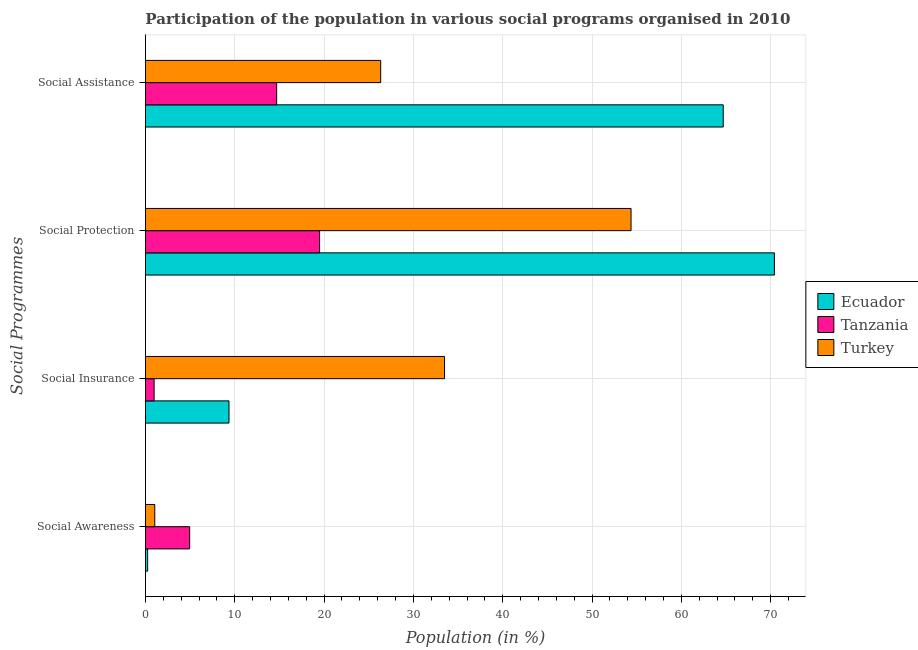How many groups of bars are there?
Your answer should be compact. 4. How many bars are there on the 3rd tick from the top?
Your answer should be compact. 3. What is the label of the 4th group of bars from the top?
Your answer should be very brief. Social Awareness. What is the participation of population in social awareness programs in Ecuador?
Your answer should be very brief. 0.25. Across all countries, what is the maximum participation of population in social protection programs?
Give a very brief answer. 70.42. Across all countries, what is the minimum participation of population in social insurance programs?
Provide a succinct answer. 0.97. In which country was the participation of population in social awareness programs maximum?
Offer a very short reply. Tanzania. In which country was the participation of population in social protection programs minimum?
Provide a succinct answer. Tanzania. What is the total participation of population in social awareness programs in the graph?
Offer a terse response. 6.24. What is the difference between the participation of population in social insurance programs in Ecuador and that in Turkey?
Make the answer very short. -24.13. What is the difference between the participation of population in social awareness programs in Turkey and the participation of population in social insurance programs in Tanzania?
Keep it short and to the point. 0.08. What is the average participation of population in social awareness programs per country?
Your answer should be compact. 2.08. What is the difference between the participation of population in social assistance programs and participation of population in social insurance programs in Ecuador?
Keep it short and to the point. 55.33. What is the ratio of the participation of population in social insurance programs in Ecuador to that in Turkey?
Your answer should be compact. 0.28. Is the participation of population in social awareness programs in Tanzania less than that in Turkey?
Offer a terse response. No. Is the difference between the participation of population in social assistance programs in Ecuador and Tanzania greater than the difference between the participation of population in social insurance programs in Ecuador and Tanzania?
Offer a terse response. Yes. What is the difference between the highest and the second highest participation of population in social awareness programs?
Offer a very short reply. 3.91. What is the difference between the highest and the lowest participation of population in social protection programs?
Your answer should be very brief. 50.92. In how many countries, is the participation of population in social insurance programs greater than the average participation of population in social insurance programs taken over all countries?
Make the answer very short. 1. What does the 3rd bar from the top in Social Assistance represents?
Keep it short and to the point. Ecuador. What does the 1st bar from the bottom in Social Protection represents?
Your answer should be compact. Ecuador. Is it the case that in every country, the sum of the participation of population in social awareness programs and participation of population in social insurance programs is greater than the participation of population in social protection programs?
Provide a succinct answer. No. How many bars are there?
Make the answer very short. 12. Are all the bars in the graph horizontal?
Provide a short and direct response. Yes. What is the difference between two consecutive major ticks on the X-axis?
Your answer should be very brief. 10. Does the graph contain grids?
Make the answer very short. Yes. Where does the legend appear in the graph?
Offer a terse response. Center right. How many legend labels are there?
Your answer should be very brief. 3. What is the title of the graph?
Keep it short and to the point. Participation of the population in various social programs organised in 2010. What is the label or title of the X-axis?
Provide a short and direct response. Population (in %). What is the label or title of the Y-axis?
Your answer should be very brief. Social Programmes. What is the Population (in %) in Ecuador in Social Awareness?
Your answer should be compact. 0.25. What is the Population (in %) in Tanzania in Social Awareness?
Make the answer very short. 4.95. What is the Population (in %) of Turkey in Social Awareness?
Make the answer very short. 1.04. What is the Population (in %) of Ecuador in Social Insurance?
Ensure brevity in your answer.  9.35. What is the Population (in %) of Tanzania in Social Insurance?
Ensure brevity in your answer.  0.97. What is the Population (in %) in Turkey in Social Insurance?
Provide a succinct answer. 33.49. What is the Population (in %) of Ecuador in Social Protection?
Your answer should be very brief. 70.42. What is the Population (in %) in Tanzania in Social Protection?
Offer a very short reply. 19.5. What is the Population (in %) in Turkey in Social Protection?
Give a very brief answer. 54.37. What is the Population (in %) of Ecuador in Social Assistance?
Provide a succinct answer. 64.69. What is the Population (in %) in Tanzania in Social Assistance?
Offer a terse response. 14.69. What is the Population (in %) of Turkey in Social Assistance?
Keep it short and to the point. 26.34. Across all Social Programmes, what is the maximum Population (in %) of Ecuador?
Provide a short and direct response. 70.42. Across all Social Programmes, what is the maximum Population (in %) in Tanzania?
Make the answer very short. 19.5. Across all Social Programmes, what is the maximum Population (in %) in Turkey?
Your answer should be compact. 54.37. Across all Social Programmes, what is the minimum Population (in %) of Ecuador?
Ensure brevity in your answer.  0.25. Across all Social Programmes, what is the minimum Population (in %) in Tanzania?
Provide a short and direct response. 0.97. Across all Social Programmes, what is the minimum Population (in %) in Turkey?
Ensure brevity in your answer.  1.04. What is the total Population (in %) in Ecuador in the graph?
Provide a short and direct response. 144.71. What is the total Population (in %) in Tanzania in the graph?
Provide a short and direct response. 40.11. What is the total Population (in %) in Turkey in the graph?
Offer a terse response. 115.24. What is the difference between the Population (in %) of Ecuador in Social Awareness and that in Social Insurance?
Give a very brief answer. -9.11. What is the difference between the Population (in %) in Tanzania in Social Awareness and that in Social Insurance?
Your answer should be compact. 3.98. What is the difference between the Population (in %) in Turkey in Social Awareness and that in Social Insurance?
Provide a succinct answer. -32.44. What is the difference between the Population (in %) in Ecuador in Social Awareness and that in Social Protection?
Make the answer very short. -70.17. What is the difference between the Population (in %) in Tanzania in Social Awareness and that in Social Protection?
Your answer should be very brief. -14.54. What is the difference between the Population (in %) in Turkey in Social Awareness and that in Social Protection?
Provide a succinct answer. -53.32. What is the difference between the Population (in %) in Ecuador in Social Awareness and that in Social Assistance?
Give a very brief answer. -64.44. What is the difference between the Population (in %) in Tanzania in Social Awareness and that in Social Assistance?
Your answer should be very brief. -9.74. What is the difference between the Population (in %) of Turkey in Social Awareness and that in Social Assistance?
Ensure brevity in your answer.  -25.29. What is the difference between the Population (in %) in Ecuador in Social Insurance and that in Social Protection?
Provide a succinct answer. -61.06. What is the difference between the Population (in %) of Tanzania in Social Insurance and that in Social Protection?
Provide a succinct answer. -18.53. What is the difference between the Population (in %) in Turkey in Social Insurance and that in Social Protection?
Offer a very short reply. -20.88. What is the difference between the Population (in %) of Ecuador in Social Insurance and that in Social Assistance?
Offer a very short reply. -55.33. What is the difference between the Population (in %) of Tanzania in Social Insurance and that in Social Assistance?
Keep it short and to the point. -13.72. What is the difference between the Population (in %) of Turkey in Social Insurance and that in Social Assistance?
Your answer should be compact. 7.15. What is the difference between the Population (in %) in Ecuador in Social Protection and that in Social Assistance?
Provide a succinct answer. 5.73. What is the difference between the Population (in %) in Tanzania in Social Protection and that in Social Assistance?
Keep it short and to the point. 4.81. What is the difference between the Population (in %) in Turkey in Social Protection and that in Social Assistance?
Provide a short and direct response. 28.03. What is the difference between the Population (in %) of Ecuador in Social Awareness and the Population (in %) of Tanzania in Social Insurance?
Ensure brevity in your answer.  -0.72. What is the difference between the Population (in %) in Ecuador in Social Awareness and the Population (in %) in Turkey in Social Insurance?
Offer a terse response. -33.24. What is the difference between the Population (in %) in Tanzania in Social Awareness and the Population (in %) in Turkey in Social Insurance?
Provide a succinct answer. -28.54. What is the difference between the Population (in %) of Ecuador in Social Awareness and the Population (in %) of Tanzania in Social Protection?
Provide a short and direct response. -19.25. What is the difference between the Population (in %) in Ecuador in Social Awareness and the Population (in %) in Turkey in Social Protection?
Your answer should be compact. -54.12. What is the difference between the Population (in %) of Tanzania in Social Awareness and the Population (in %) of Turkey in Social Protection?
Your answer should be very brief. -49.42. What is the difference between the Population (in %) in Ecuador in Social Awareness and the Population (in %) in Tanzania in Social Assistance?
Ensure brevity in your answer.  -14.44. What is the difference between the Population (in %) in Ecuador in Social Awareness and the Population (in %) in Turkey in Social Assistance?
Your answer should be very brief. -26.09. What is the difference between the Population (in %) in Tanzania in Social Awareness and the Population (in %) in Turkey in Social Assistance?
Your answer should be compact. -21.39. What is the difference between the Population (in %) of Ecuador in Social Insurance and the Population (in %) of Tanzania in Social Protection?
Ensure brevity in your answer.  -10.14. What is the difference between the Population (in %) in Ecuador in Social Insurance and the Population (in %) in Turkey in Social Protection?
Your response must be concise. -45.01. What is the difference between the Population (in %) in Tanzania in Social Insurance and the Population (in %) in Turkey in Social Protection?
Your answer should be compact. -53.4. What is the difference between the Population (in %) in Ecuador in Social Insurance and the Population (in %) in Tanzania in Social Assistance?
Your answer should be compact. -5.34. What is the difference between the Population (in %) in Ecuador in Social Insurance and the Population (in %) in Turkey in Social Assistance?
Give a very brief answer. -16.98. What is the difference between the Population (in %) of Tanzania in Social Insurance and the Population (in %) of Turkey in Social Assistance?
Your answer should be compact. -25.37. What is the difference between the Population (in %) in Ecuador in Social Protection and the Population (in %) in Tanzania in Social Assistance?
Your response must be concise. 55.73. What is the difference between the Population (in %) of Ecuador in Social Protection and the Population (in %) of Turkey in Social Assistance?
Offer a terse response. 44.08. What is the difference between the Population (in %) in Tanzania in Social Protection and the Population (in %) in Turkey in Social Assistance?
Provide a short and direct response. -6.84. What is the average Population (in %) of Ecuador per Social Programmes?
Your answer should be compact. 36.18. What is the average Population (in %) of Tanzania per Social Programmes?
Your answer should be very brief. 10.03. What is the average Population (in %) in Turkey per Social Programmes?
Offer a very short reply. 28.81. What is the difference between the Population (in %) of Ecuador and Population (in %) of Tanzania in Social Awareness?
Ensure brevity in your answer.  -4.71. What is the difference between the Population (in %) of Ecuador and Population (in %) of Turkey in Social Awareness?
Keep it short and to the point. -0.8. What is the difference between the Population (in %) of Tanzania and Population (in %) of Turkey in Social Awareness?
Your response must be concise. 3.91. What is the difference between the Population (in %) of Ecuador and Population (in %) of Tanzania in Social Insurance?
Provide a short and direct response. 8.39. What is the difference between the Population (in %) of Ecuador and Population (in %) of Turkey in Social Insurance?
Make the answer very short. -24.13. What is the difference between the Population (in %) in Tanzania and Population (in %) in Turkey in Social Insurance?
Your answer should be compact. -32.52. What is the difference between the Population (in %) in Ecuador and Population (in %) in Tanzania in Social Protection?
Offer a terse response. 50.92. What is the difference between the Population (in %) in Ecuador and Population (in %) in Turkey in Social Protection?
Keep it short and to the point. 16.05. What is the difference between the Population (in %) of Tanzania and Population (in %) of Turkey in Social Protection?
Provide a short and direct response. -34.87. What is the difference between the Population (in %) in Ecuador and Population (in %) in Tanzania in Social Assistance?
Provide a short and direct response. 50. What is the difference between the Population (in %) of Ecuador and Population (in %) of Turkey in Social Assistance?
Your response must be concise. 38.35. What is the difference between the Population (in %) of Tanzania and Population (in %) of Turkey in Social Assistance?
Your answer should be compact. -11.65. What is the ratio of the Population (in %) in Ecuador in Social Awareness to that in Social Insurance?
Give a very brief answer. 0.03. What is the ratio of the Population (in %) of Tanzania in Social Awareness to that in Social Insurance?
Give a very brief answer. 5.11. What is the ratio of the Population (in %) of Turkey in Social Awareness to that in Social Insurance?
Ensure brevity in your answer.  0.03. What is the ratio of the Population (in %) in Ecuador in Social Awareness to that in Social Protection?
Make the answer very short. 0. What is the ratio of the Population (in %) of Tanzania in Social Awareness to that in Social Protection?
Your response must be concise. 0.25. What is the ratio of the Population (in %) in Turkey in Social Awareness to that in Social Protection?
Ensure brevity in your answer.  0.02. What is the ratio of the Population (in %) in Ecuador in Social Awareness to that in Social Assistance?
Your answer should be compact. 0. What is the ratio of the Population (in %) of Tanzania in Social Awareness to that in Social Assistance?
Ensure brevity in your answer.  0.34. What is the ratio of the Population (in %) of Turkey in Social Awareness to that in Social Assistance?
Provide a short and direct response. 0.04. What is the ratio of the Population (in %) in Ecuador in Social Insurance to that in Social Protection?
Your response must be concise. 0.13. What is the ratio of the Population (in %) of Tanzania in Social Insurance to that in Social Protection?
Your response must be concise. 0.05. What is the ratio of the Population (in %) in Turkey in Social Insurance to that in Social Protection?
Offer a very short reply. 0.62. What is the ratio of the Population (in %) in Ecuador in Social Insurance to that in Social Assistance?
Your response must be concise. 0.14. What is the ratio of the Population (in %) in Tanzania in Social Insurance to that in Social Assistance?
Your answer should be very brief. 0.07. What is the ratio of the Population (in %) in Turkey in Social Insurance to that in Social Assistance?
Provide a short and direct response. 1.27. What is the ratio of the Population (in %) of Ecuador in Social Protection to that in Social Assistance?
Give a very brief answer. 1.09. What is the ratio of the Population (in %) of Tanzania in Social Protection to that in Social Assistance?
Ensure brevity in your answer.  1.33. What is the ratio of the Population (in %) in Turkey in Social Protection to that in Social Assistance?
Keep it short and to the point. 2.06. What is the difference between the highest and the second highest Population (in %) in Ecuador?
Keep it short and to the point. 5.73. What is the difference between the highest and the second highest Population (in %) of Tanzania?
Your answer should be very brief. 4.81. What is the difference between the highest and the second highest Population (in %) of Turkey?
Offer a terse response. 20.88. What is the difference between the highest and the lowest Population (in %) of Ecuador?
Provide a short and direct response. 70.17. What is the difference between the highest and the lowest Population (in %) in Tanzania?
Ensure brevity in your answer.  18.53. What is the difference between the highest and the lowest Population (in %) of Turkey?
Offer a terse response. 53.32. 